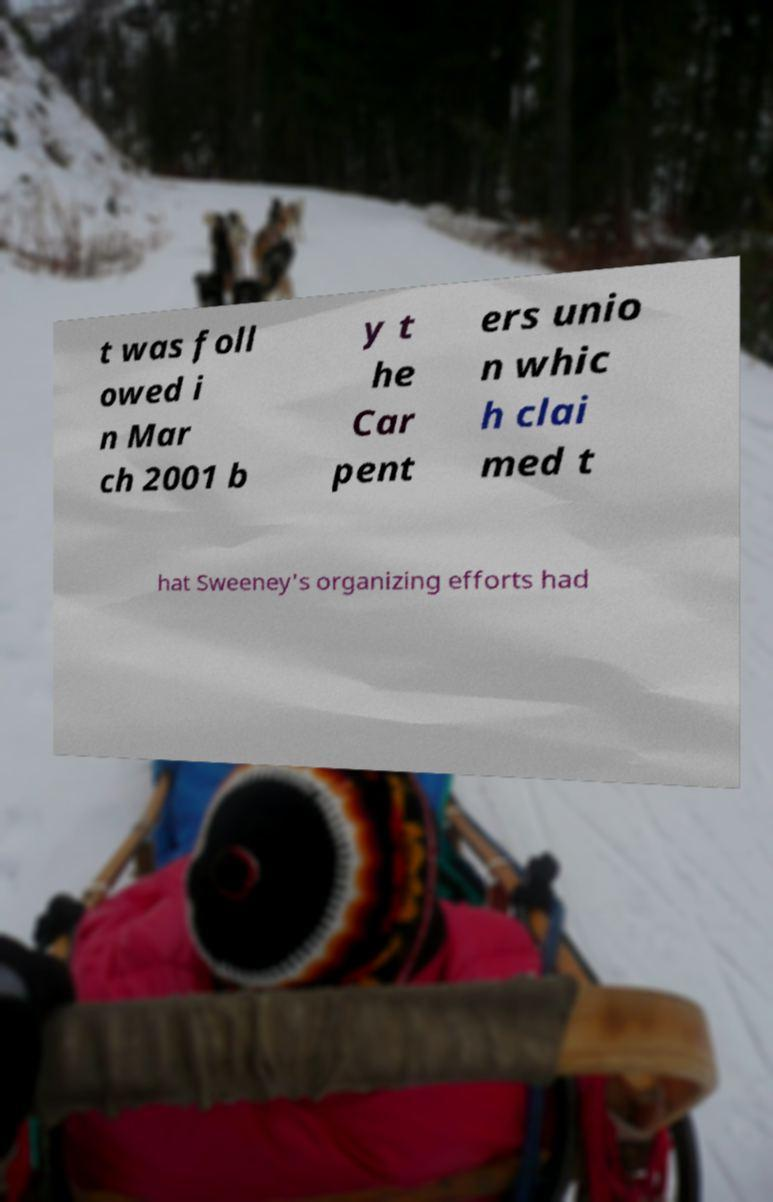Could you extract and type out the text from this image? t was foll owed i n Mar ch 2001 b y t he Car pent ers unio n whic h clai med t hat Sweeney's organizing efforts had 